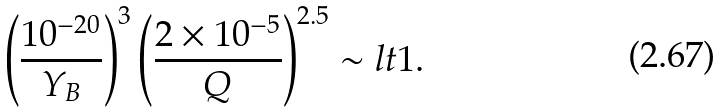Convert formula to latex. <formula><loc_0><loc_0><loc_500><loc_500>\left ( \frac { 1 0 ^ { - 2 0 } } { Y _ { B } } \right ) ^ { 3 } \left ( \frac { 2 \times 1 0 ^ { - 5 } } { Q } \right ) ^ { 2 . 5 } \sim l t 1 .</formula> 